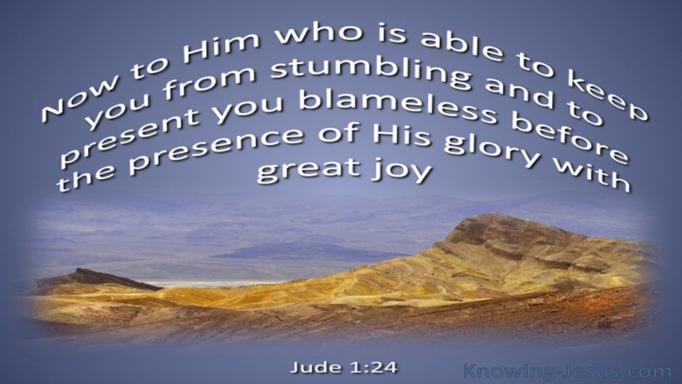How can the concept of being presented 'blameless' impact a believer's daily life? The concept of being presented 'blameless' as mentioned in Jude 1:24 can profoundly affect a believer's daily life by instilling a sense of comfort and motivation. Knowing that God's grace covers their shortcomings can encourage believers to live righteously and joyfully, while perpetually striving towards holiness without fear of judgment, trusting in His redemptive power. 